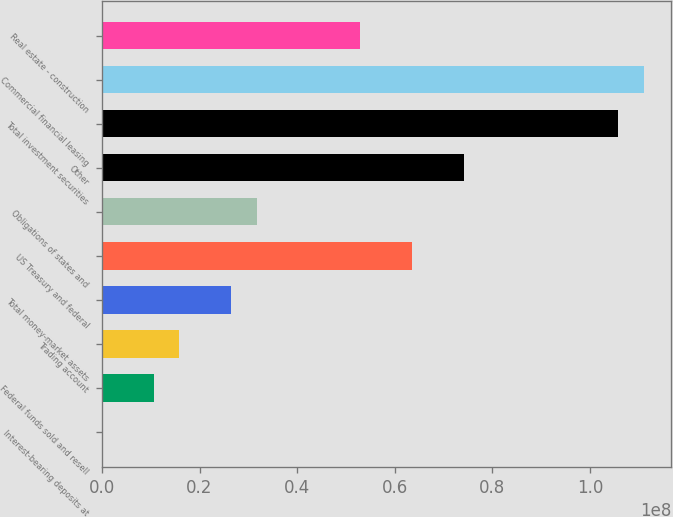Convert chart to OTSL. <chart><loc_0><loc_0><loc_500><loc_500><bar_chart><fcel>Interest-bearing deposits at<fcel>Federal funds sold and resell<fcel>Trading account<fcel>Total money-market assets<fcel>US Treasury and federal<fcel>Obligations of states and<fcel>Other<fcel>Total investment securities<fcel>Commercial financial leasing<fcel>Real estate - construction<nl><fcel>10242<fcel>1.05959e+07<fcel>1.58888e+07<fcel>2.64745e+07<fcel>6.35244e+07<fcel>3.17673e+07<fcel>7.41101e+07<fcel>1.05867e+08<fcel>1.1116e+08<fcel>5.29387e+07<nl></chart> 